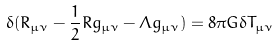<formula> <loc_0><loc_0><loc_500><loc_500>\delta ( R _ { \mu \nu } - \frac { 1 } { 2 } R g _ { \mu \nu } - \Lambda g _ { \mu \nu } ) = 8 \pi G \delta T _ { \mu \nu }</formula> 